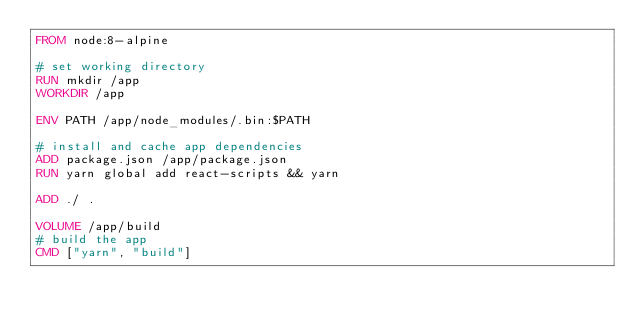Convert code to text. <code><loc_0><loc_0><loc_500><loc_500><_Dockerfile_>FROM node:8-alpine

# set working directory
RUN mkdir /app
WORKDIR /app

ENV PATH /app/node_modules/.bin:$PATH

# install and cache app dependencies
ADD package.json /app/package.json
RUN yarn global add react-scripts && yarn 

ADD ./ .

VOLUME /app/build
# build the app
CMD ["yarn", "build"]
</code> 